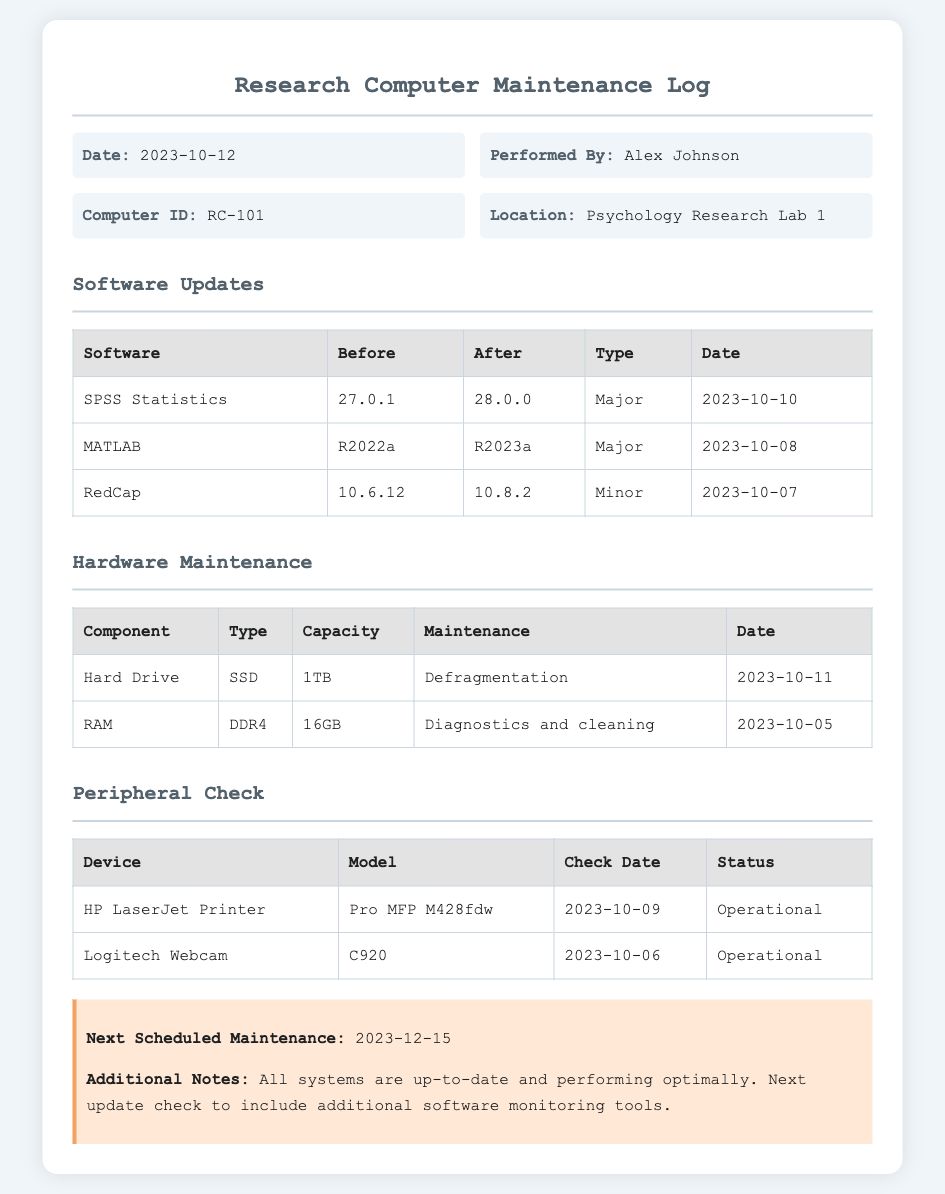What is the date of the maintenance log? The date of the maintenance log is specified in the header section of the document.
Answer: 2023-10-12 Who performed the maintenance? The name of the person who performed the maintenance is mentioned in the info grid.
Answer: Alex Johnson What is the Computer ID? The Computer ID is listed in the info grid of the document.
Answer: RC-101 What was the software update for SPSS Statistics? The software update details for SPSS Statistics can be found in the Software Updates table.
Answer: 28.0.0 How much RAM does the computer have? The RAM information is provided in the Hardware Maintenance section of the document.
Answer: 16GB What is the maintenance activity for the Hard Drive? The maintenance activity for the Hard Drive is described in the Hardware Maintenance table.
Answer: Defragmentation What is the status of the HP LaserJet Printer? The status of the HP LaserJet Printer is mentioned in the Peripheral Check table.
Answer: Operational When is the next scheduled maintenance? The next scheduled maintenance date is indicated in the note section of the document.
Answer: 2023-12-15 What type of drive is mentioned for maintenance? The type of drive is specified in the description of the Hard Drive in the Hardware Maintenance section.
Answer: SSD 